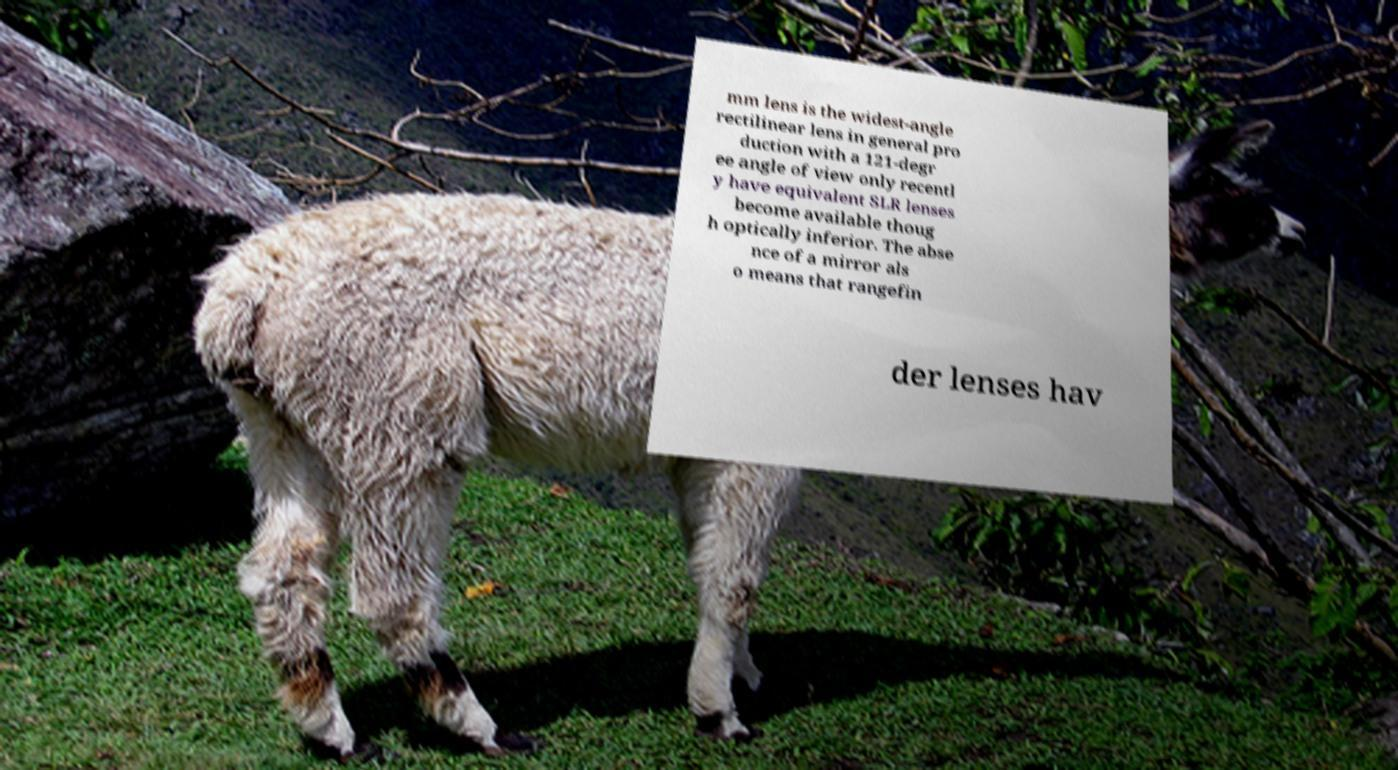I need the written content from this picture converted into text. Can you do that? mm lens is the widest-angle rectilinear lens in general pro duction with a 121-degr ee angle of view only recentl y have equivalent SLR lenses become available thoug h optically inferior. The abse nce of a mirror als o means that rangefin der lenses hav 